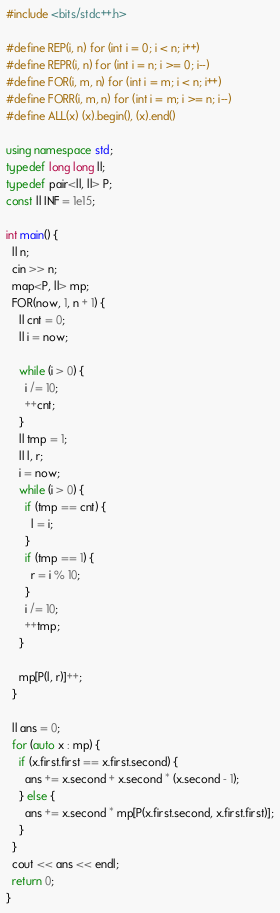Convert code to text. <code><loc_0><loc_0><loc_500><loc_500><_C++_>#include <bits/stdc++.h>

#define REP(i, n) for (int i = 0; i < n; i++)
#define REPR(i, n) for (int i = n; i >= 0; i--)
#define FOR(i, m, n) for (int i = m; i < n; i++)
#define FORR(i, m, n) for (int i = m; i >= n; i--)
#define ALL(x) (x).begin(), (x).end()

using namespace std;
typedef long long ll;
typedef pair<ll, ll> P;
const ll INF = 1e15;

int main() {
  ll n;
  cin >> n;
  map<P, ll> mp;
  FOR(now, 1, n + 1) {
    ll cnt = 0;
    ll i = now;

    while (i > 0) {
      i /= 10;
      ++cnt;
    }
    ll tmp = 1;
    ll l, r;
    i = now;
    while (i > 0) {
      if (tmp == cnt) {
        l = i;
      }
      if (tmp == 1) {
        r = i % 10;
      }
      i /= 10;
      ++tmp;
    }

    mp[P(l, r)]++;
  }

  ll ans = 0;
  for (auto x : mp) {
    if (x.first.first == x.first.second) {
      ans += x.second + x.second * (x.second - 1);
    } else {
      ans += x.second * mp[P(x.first.second, x.first.first)];
    }
  }
  cout << ans << endl;
  return 0;
}</code> 